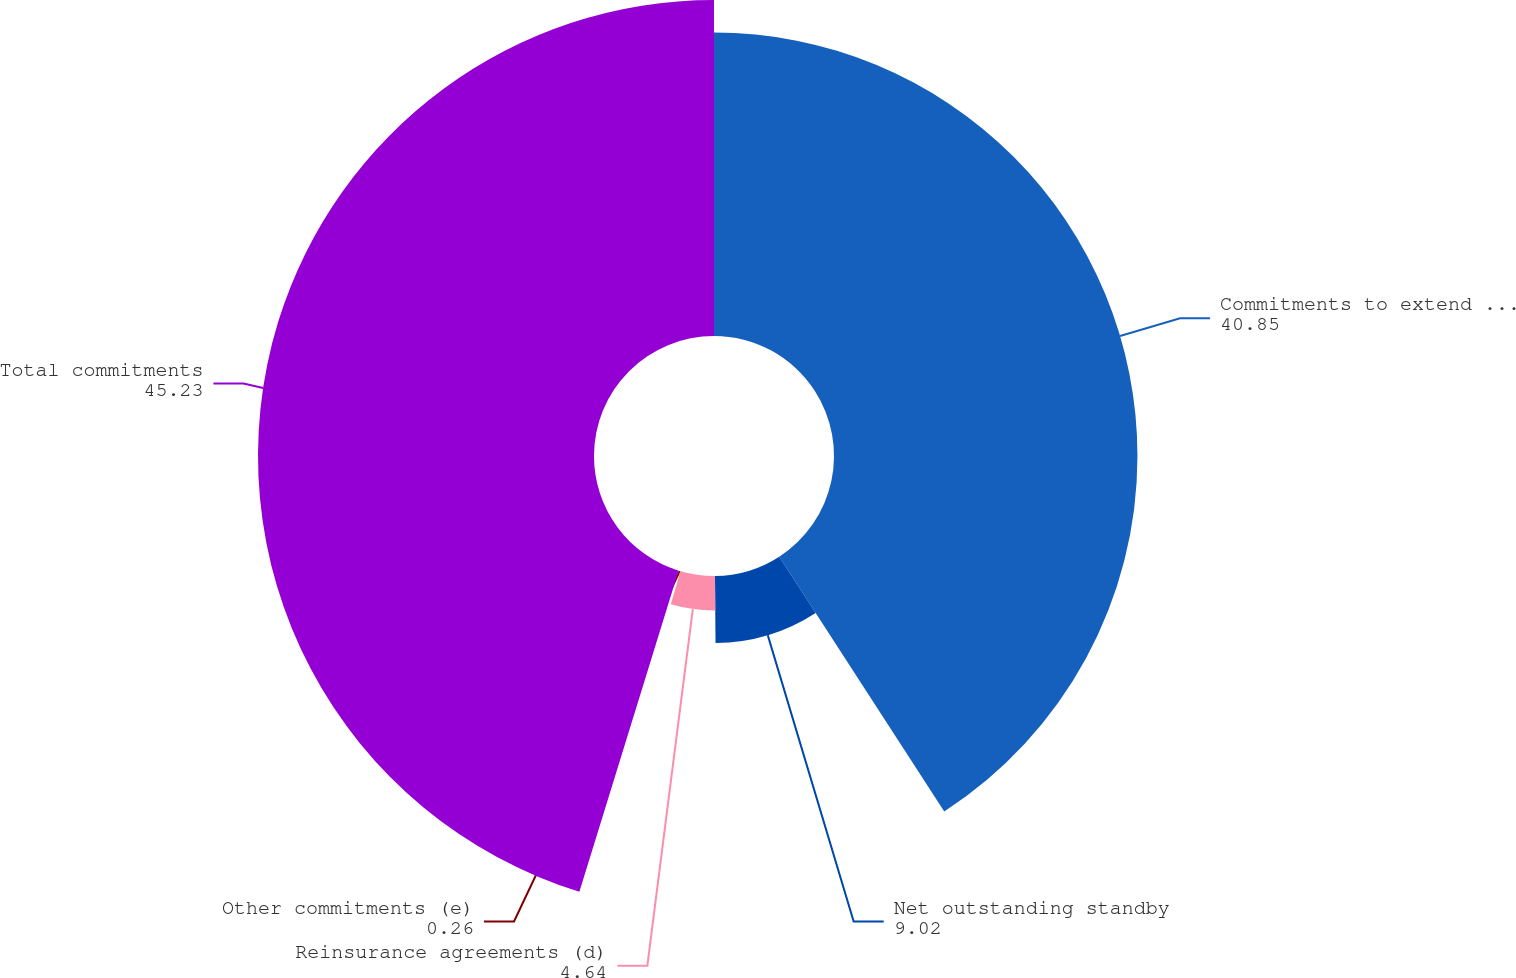<chart> <loc_0><loc_0><loc_500><loc_500><pie_chart><fcel>Commitments to extend credit<fcel>Net outstanding standby<fcel>Reinsurance agreements (d)<fcel>Other commitments (e)<fcel>Total commitments<nl><fcel>40.85%<fcel>9.02%<fcel>4.64%<fcel>0.26%<fcel>45.23%<nl></chart> 